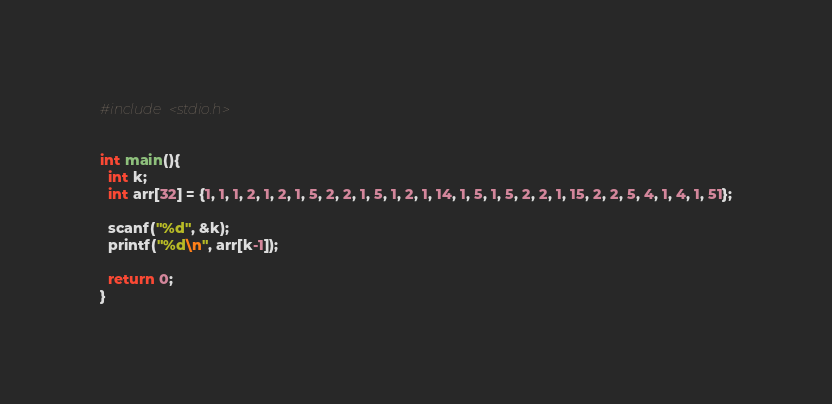Convert code to text. <code><loc_0><loc_0><loc_500><loc_500><_C_>#include <stdio.h>


int main(){
  int k;
  int arr[32] = {1, 1, 1, 2, 1, 2, 1, 5, 2, 2, 1, 5, 1, 2, 1, 14, 1, 5, 1, 5, 2, 2, 1, 15, 2, 2, 5, 4, 1, 4, 1, 51};

  scanf("%d", &k);
  printf("%d\n", arr[k-1]);

  return 0;
}</code> 